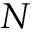<formula> <loc_0><loc_0><loc_500><loc_500>N</formula> 